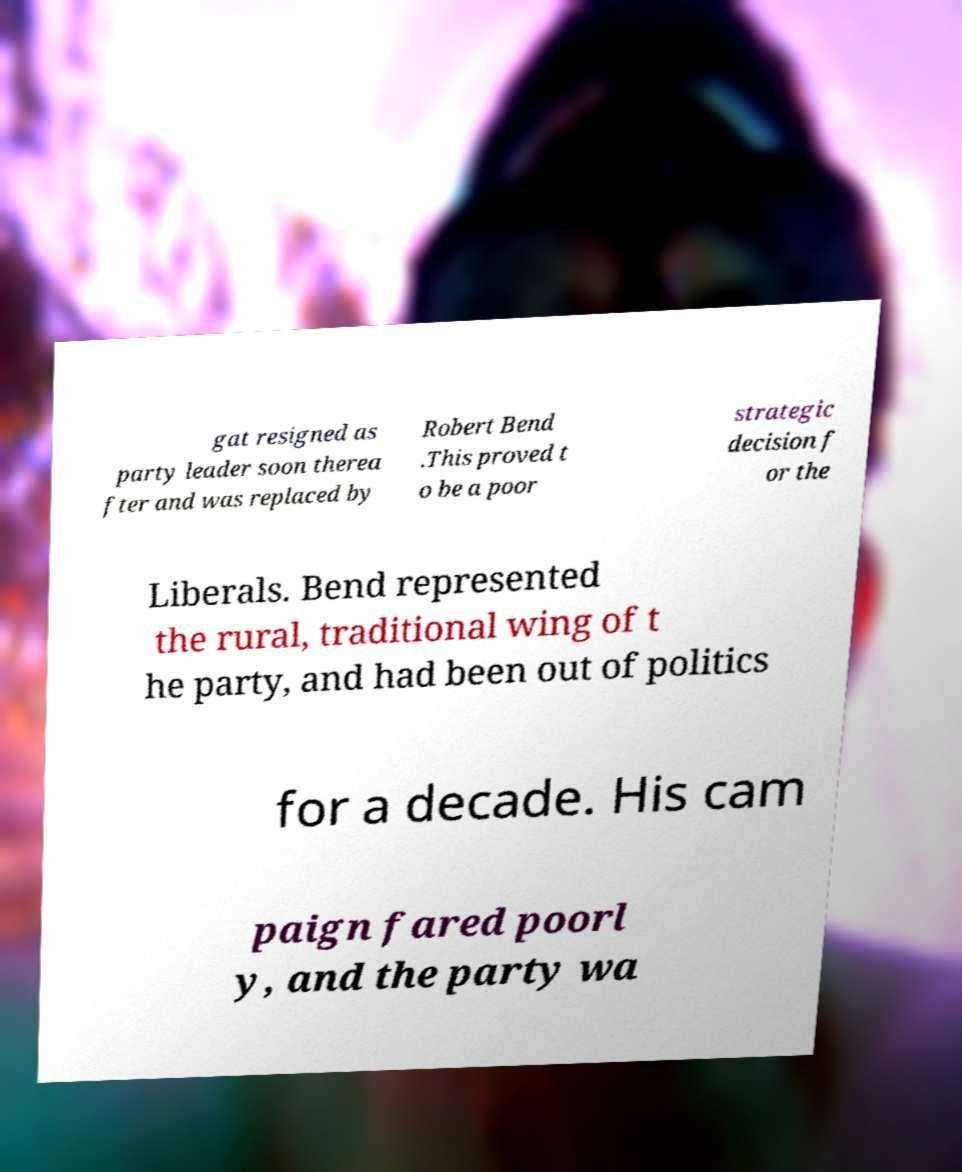Can you accurately transcribe the text from the provided image for me? gat resigned as party leader soon therea fter and was replaced by Robert Bend .This proved t o be a poor strategic decision f or the Liberals. Bend represented the rural, traditional wing of t he party, and had been out of politics for a decade. His cam paign fared poorl y, and the party wa 